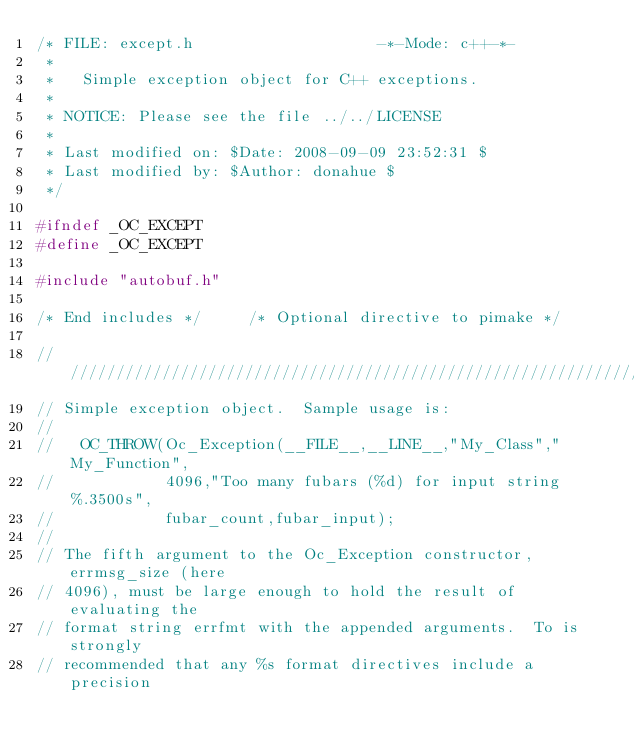Convert code to text. <code><loc_0><loc_0><loc_500><loc_500><_C_>/* FILE: except.h                    -*-Mode: c++-*-
 *
 *   Simple exception object for C++ exceptions.
 * 
 * NOTICE: Please see the file ../../LICENSE
 *
 * Last modified on: $Date: 2008-09-09 23:52:31 $
 * Last modified by: $Author: donahue $
 */

#ifndef _OC_EXCEPT
#define _OC_EXCEPT

#include "autobuf.h"

/* End includes */     /* Optional directive to pimake */

////////////////////////////////////////////////////////////////////////
// Simple exception object.  Sample usage is:
//
//   OC_THROW(Oc_Exception(__FILE__,__LINE__,"My_Class","My_Function",
//            4096,"Too many fubars (%d) for input string %.3500s",
//            fubar_count,fubar_input);
//
// The fifth argument to the Oc_Exception constructor, errmsg_size (here
// 4096), must be large enough to hold the result of evaluating the
// format string errfmt with the appended arguments.  To is strongly
// recommended that any %s format directives include a precision</code> 